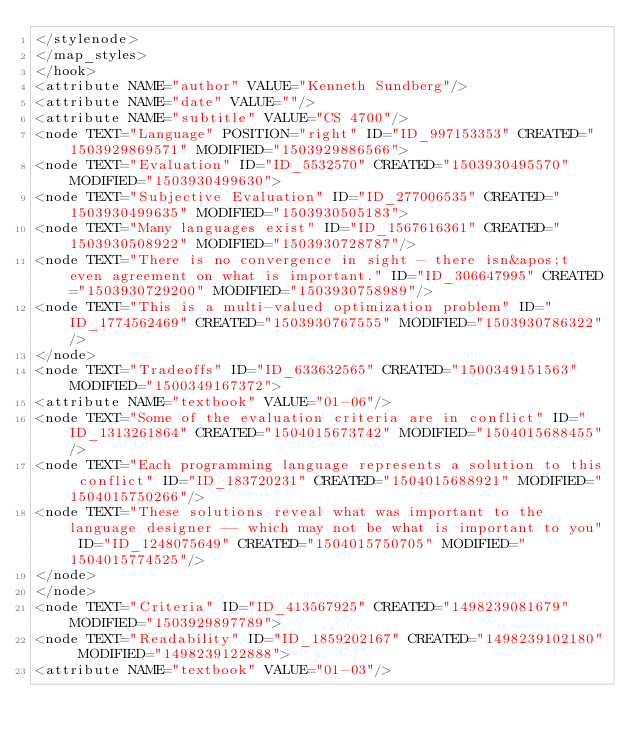Convert code to text. <code><loc_0><loc_0><loc_500><loc_500><_ObjectiveC_></stylenode>
</map_styles>
</hook>
<attribute NAME="author" VALUE="Kenneth Sundberg"/>
<attribute NAME="date" VALUE=""/>
<attribute NAME="subtitle" VALUE="CS 4700"/>
<node TEXT="Language" POSITION="right" ID="ID_997153353" CREATED="1503929869571" MODIFIED="1503929886566">
<node TEXT="Evaluation" ID="ID_5532570" CREATED="1503930495570" MODIFIED="1503930499630">
<node TEXT="Subjective Evaluation" ID="ID_277006535" CREATED="1503930499635" MODIFIED="1503930505183">
<node TEXT="Many languages exist" ID="ID_1567616361" CREATED="1503930508922" MODIFIED="1503930728787"/>
<node TEXT="There is no convergence in sight - there isn&apos;t even agreement on what is important." ID="ID_306647995" CREATED="1503930729200" MODIFIED="1503930758989"/>
<node TEXT="This is a multi-valued optimization problem" ID="ID_1774562469" CREATED="1503930767555" MODIFIED="1503930786322"/>
</node>
<node TEXT="Tradeoffs" ID="ID_633632565" CREATED="1500349151563" MODIFIED="1500349167372">
<attribute NAME="textbook" VALUE="01-06"/>
<node TEXT="Some of the evaluation criteria are in conflict" ID="ID_1313261864" CREATED="1504015673742" MODIFIED="1504015688455"/>
<node TEXT="Each programming language represents a solution to this conflict" ID="ID_183720231" CREATED="1504015688921" MODIFIED="1504015750266"/>
<node TEXT="These solutions reveal what was important to the language designer -- which may not be what is important to you" ID="ID_1248075649" CREATED="1504015750705" MODIFIED="1504015774525"/>
</node>
</node>
<node TEXT="Criteria" ID="ID_413567925" CREATED="1498239081679" MODIFIED="1503929897789">
<node TEXT="Readability" ID="ID_1859202167" CREATED="1498239102180" MODIFIED="1498239122888">
<attribute NAME="textbook" VALUE="01-03"/></code> 